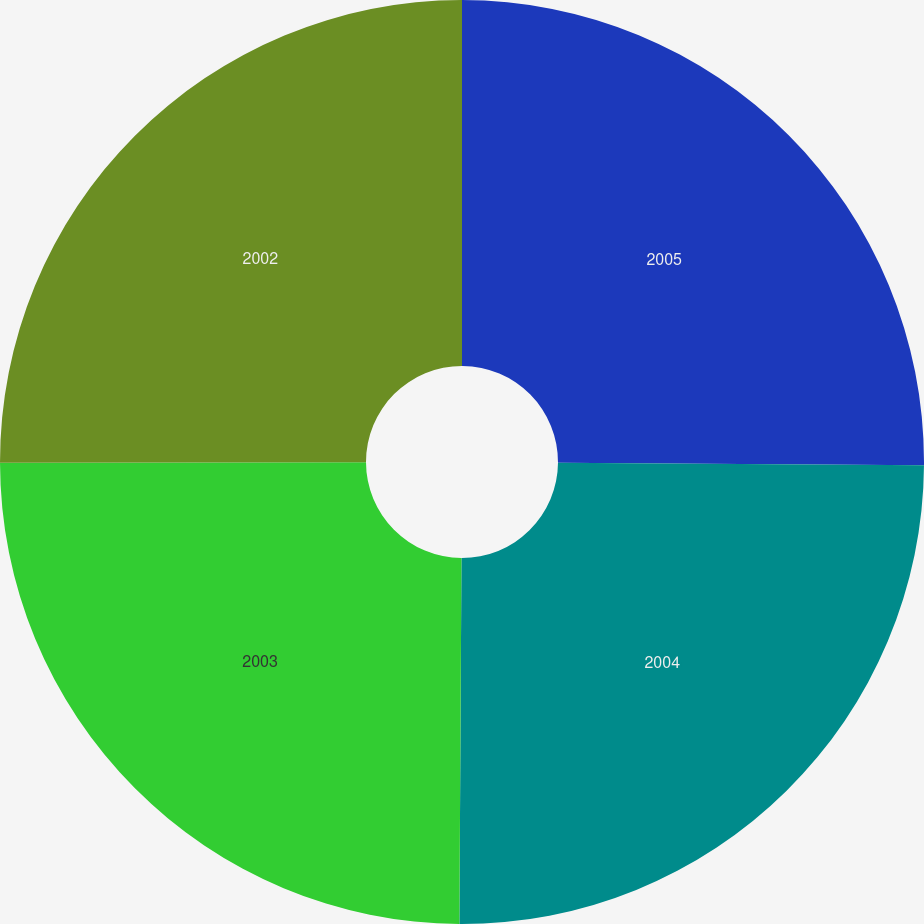Convert chart. <chart><loc_0><loc_0><loc_500><loc_500><pie_chart><fcel>2005<fcel>2004<fcel>2003<fcel>2002<nl><fcel>25.11%<fcel>24.98%<fcel>24.88%<fcel>25.03%<nl></chart> 